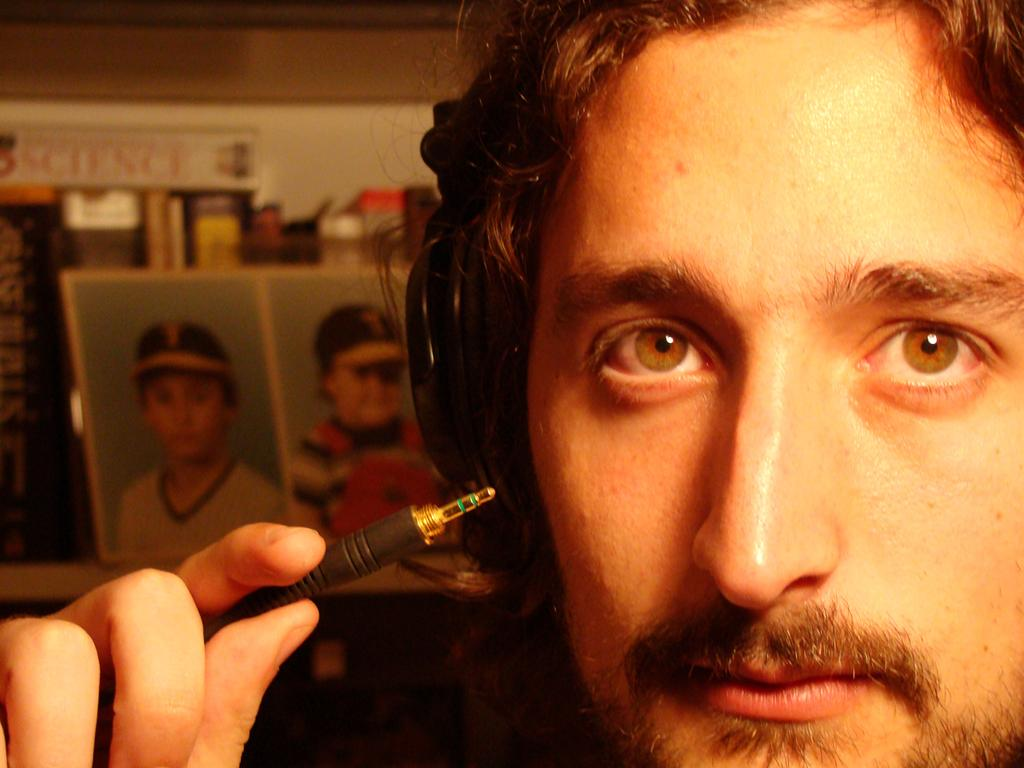What is the main subject of the image? There is a person in the image. What is the person holding in his hand? The person is holding a jack pin in his hand. What can be seen in the background of the image? There is a photo frame and books on a table in the background of the image. What type of insurance policy is the person discussing in the image? There is no indication in the image that the person is discussing any type of insurance policy. 